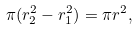Convert formula to latex. <formula><loc_0><loc_0><loc_500><loc_500>\pi ( r _ { 2 } ^ { 2 } - r _ { 1 } ^ { 2 } ) = \pi r ^ { 2 } ,</formula> 